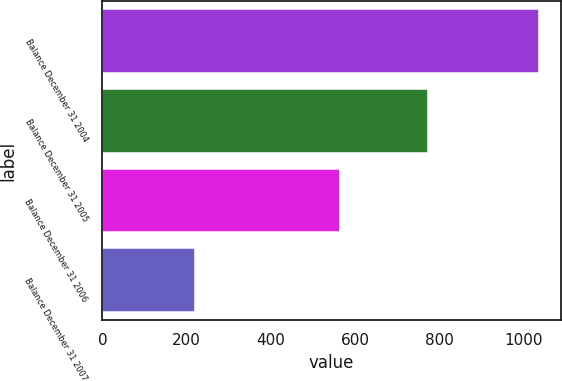Convert chart to OTSL. <chart><loc_0><loc_0><loc_500><loc_500><bar_chart><fcel>Balance December 31 2004<fcel>Balance December 31 2005<fcel>Balance December 31 2006<fcel>Balance December 31 2007<nl><fcel>1037<fcel>774<fcel>565<fcel>219<nl></chart> 